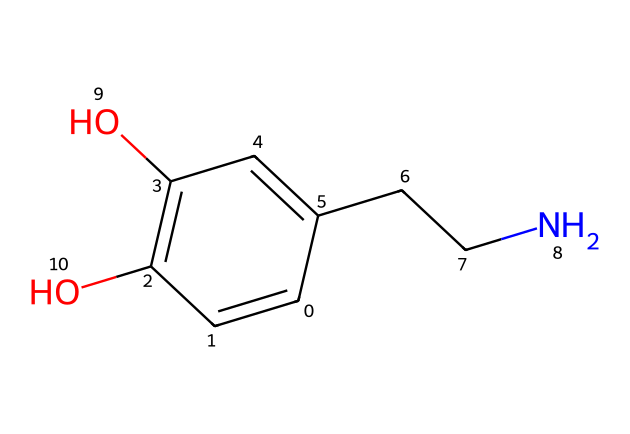What is the molecular formula of the compound? By analyzing the SMILES representation, we can identify the number of atoms present. The fragment C1=CC(=C(C=C1CCN)O)O indicates there are carbon (C), hydrogen (H), nitrogen (N), and oxygen (O) atoms. Counting these gives us C8H11NO3.
Answer: C8H11NO3 How many carbon atoms are in the structure? The SMILES shows multiple carbon atoms represented by 'C'. Count the 'C's in the structure: C1, C, C, C, C1, CC. This totals to 8 carbon atoms.
Answer: 8 What functional groups are present in this chemical? Analyzing the structure reveals hydroxyl groups (-OH) and an amine group (-NH2) near nitrogen. The two '-OH' groups suggest it has phenolic characteristics. Therefore, the functional groups are alcohol and amine.
Answer: alcohol and amine What role does dopamine play in behavior? Dopamine, as indicated in the context, is a neurotransmitter involved in the reward-seeking behavior. It influences motivation, pleasure, and reinforcement of behaviors that lead to rewards.
Answer: neurotransmitter What might the presence of the amine group suggest about its properties? The amine group (-NH2) in the chemical structure is indicative of basicity and the ability to form hydrogen bonds, which can enhance solubility in biological systems and affect the reactivity of the chemical.
Answer: basicity How does the hydroxyl group influence its solubility? The hydroxyl groups (-OH) facilitate hydrogen bonding with water molecules, significantly increasing the solubility of the compound in aqueous environments, thereby influencing its biological interactions and functions.
Answer: increases solubility 